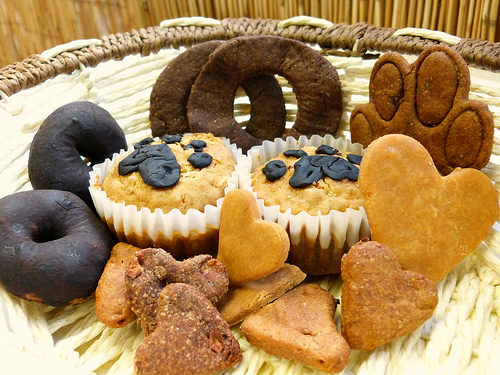<image>
Is there a muffin in the basket? Yes. The muffin is contained within or inside the basket, showing a containment relationship. 